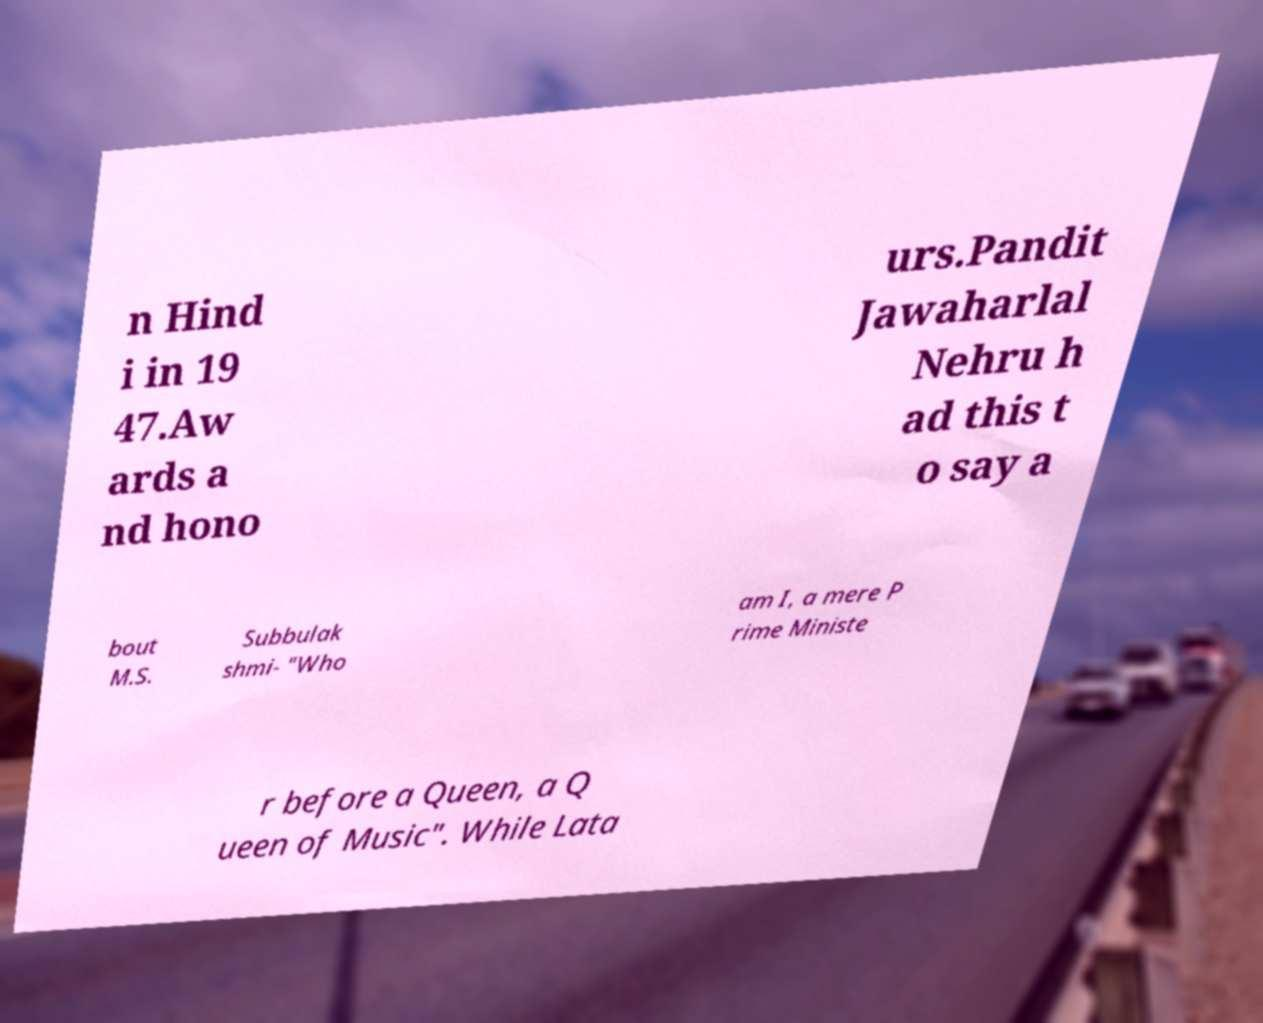I need the written content from this picture converted into text. Can you do that? n Hind i in 19 47.Aw ards a nd hono urs.Pandit Jawaharlal Nehru h ad this t o say a bout M.S. Subbulak shmi- "Who am I, a mere P rime Ministe r before a Queen, a Q ueen of Music". While Lata 